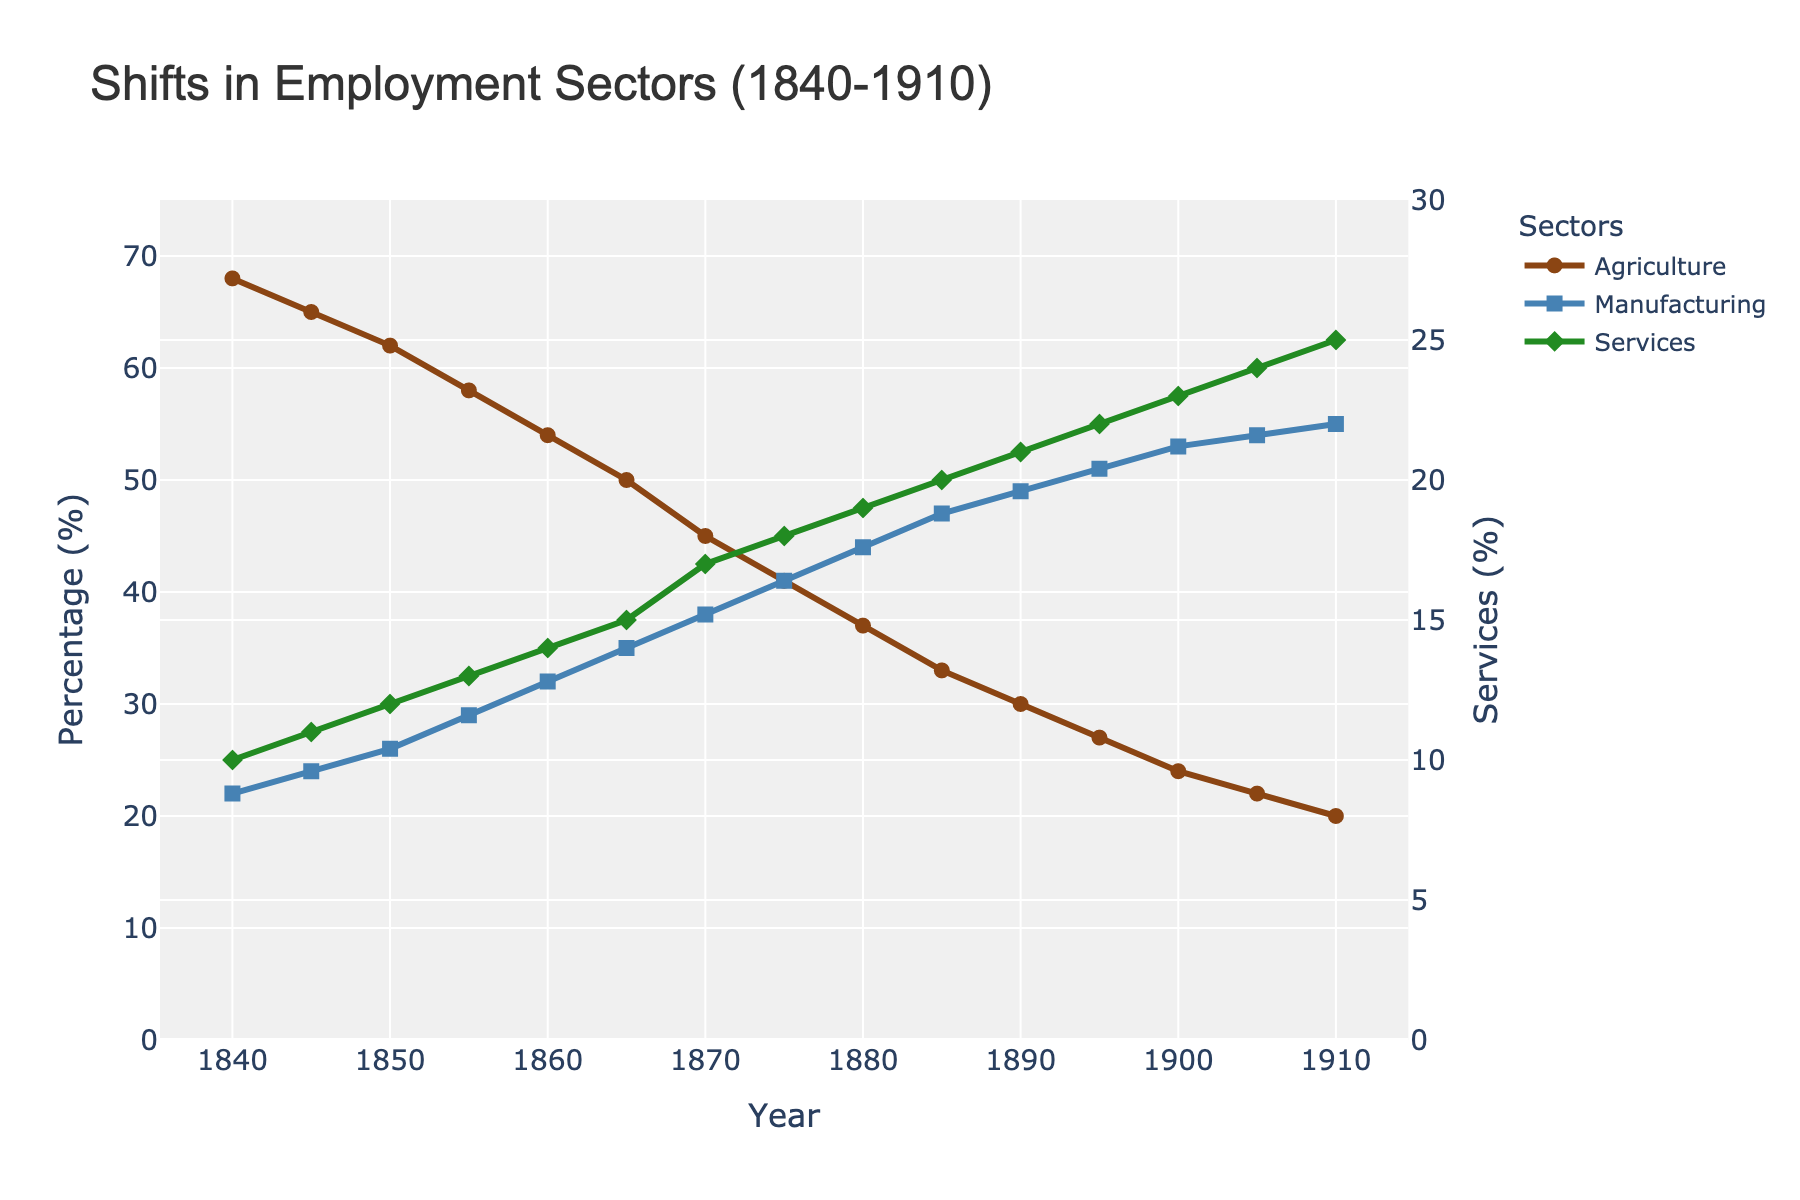What year did the Manufacturing sector surpass the Agriculture sector in employment percentage? Follow the lines for both Agriculture and Manufacturing sectors. The crossover occurs between 1870 and 1875. Verify that in 1875, Manufacturing exceeds Agriculture (41% vs. 41%, essentially the same, but increase continues thereafter).
Answer: 1875 Which sector had the most significant change in employment percentage from 1840 to 1910? Look at the initial and final values for each sector. Agriculture dropped from 68% to 20%, a 48% decrease. Compare this to Manufacturing (increased by 33%) and Services (increased by 15%). Agriculture had the largest change.
Answer: Agriculture In what years did Services see an increase in employment percentage by 2% or more compared to the previous 5 years? Calculate the increase in Services every 5 years: 1840-1845 (1%), 1845-1850 (1%), 1850-1855 (1%), 1855-1860 (1%), 1860-1865 (1%), 1865-1870 (2%), 1870-1875 (1%), 1875-1880 (1%), 1880-1885 (1%), 1885-1890 (1%), 1890-1895 (1%), 1895-1900 (1%), 1900-1905 (1%), 1905-1910 (1%). The only notable increase by 2% or more is 1865-1870.
Answer: 1870 Which sector had the highest employment percentage in 1905? Observe the percentages in 1905 for each sector: Agriculture (22%), Manufacturing (54%), and Services (24%). Manufacturing is the highest.
Answer: Manufacturing How did the employment percentage for the Services sector change from 1860 to 1900? Compare the Services percentages in 1860 (14%) and 1900 (23%). The change is calculated as 23% - 14%.
Answer: 9% increase What was the difference in employment percentage between Agriculture and Manufacturing in 1850? Subtract Manufacturing percentage from Agriculture percentage for 1850: 62% - 26%.
Answer: 36% Which sector witnessed a continuous increase throughout the period from 1840 to 1910? Check the trend for each sector by following the lines from 1840 to 1910. Only the Manufacturing sector shows a continuous rise.
Answer: Manufacturing What is the average employment percentage of the Agriculture sector over the entire period? Sum the percentages from 1840 to 1910 for Agriculture and divide by the number of data points (71 + 68 + 65 + ... + 22 + 20). (68 + 65 + 62 + 58 + 54 + 50 + 45 + 41 + 37 + 33 + 30 + 27 + 24 + 22 + 20)/15 = 40%.
Answer: 40% In which decade did the Services sector experience the highest growth in employment percentage? Compare decade-wise growth: 1840-1850 (2%), 1850-1860 (2%), 1860-1870 (3%), 1870-1880 (2%), 1880-1890 (2%), 1890-1900 (2%). The highest growth was between 1860-1870.
Answer: 1860-1870 